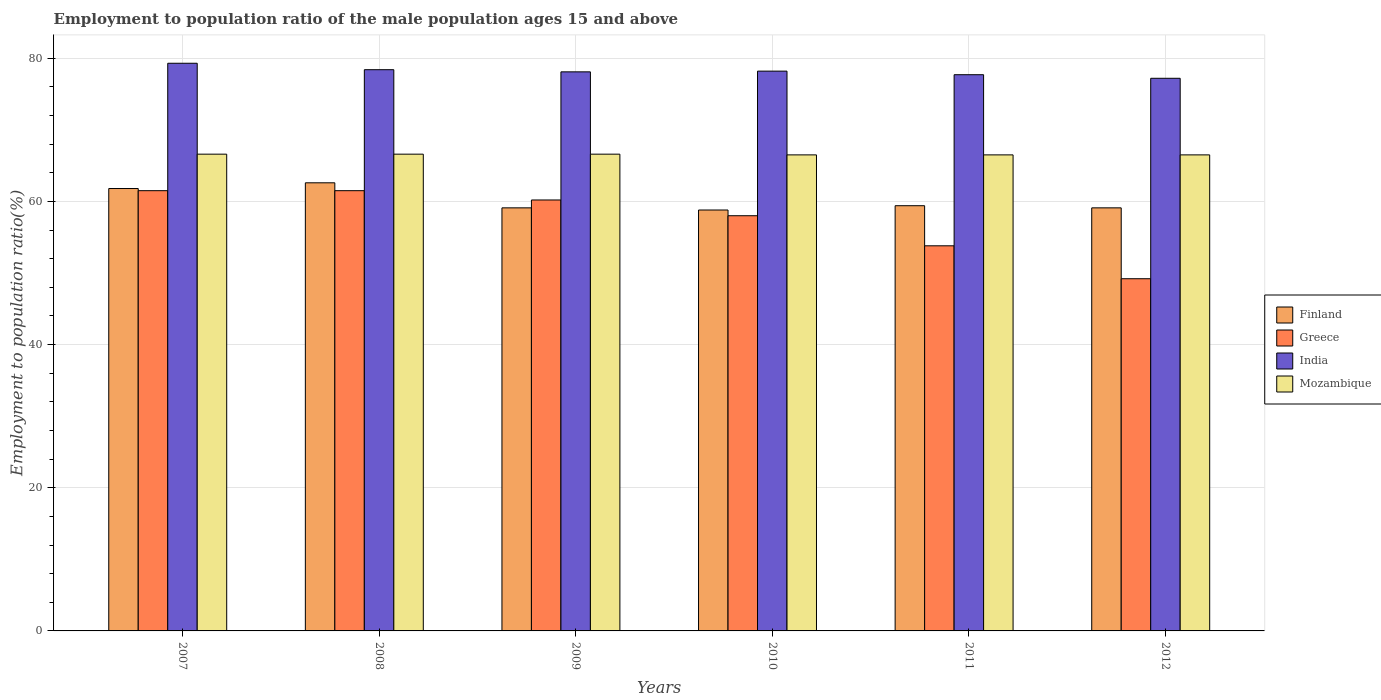Are the number of bars per tick equal to the number of legend labels?
Your answer should be very brief. Yes. Are the number of bars on each tick of the X-axis equal?
Offer a terse response. Yes. How many bars are there on the 3rd tick from the left?
Make the answer very short. 4. How many bars are there on the 4th tick from the right?
Offer a very short reply. 4. What is the label of the 4th group of bars from the left?
Offer a terse response. 2010. What is the employment to population ratio in Finland in 2012?
Offer a very short reply. 59.1. Across all years, what is the maximum employment to population ratio in India?
Provide a short and direct response. 79.3. Across all years, what is the minimum employment to population ratio in India?
Your response must be concise. 77.2. In which year was the employment to population ratio in Mozambique minimum?
Your answer should be very brief. 2010. What is the total employment to population ratio in Finland in the graph?
Your answer should be compact. 360.8. What is the difference between the employment to population ratio in Greece in 2010 and that in 2011?
Provide a succinct answer. 4.2. What is the difference between the employment to population ratio in Finland in 2010 and the employment to population ratio in Mozambique in 2009?
Offer a very short reply. -7.8. What is the average employment to population ratio in Mozambique per year?
Your answer should be very brief. 66.55. In the year 2011, what is the difference between the employment to population ratio in Mozambique and employment to population ratio in India?
Provide a short and direct response. -11.2. What is the ratio of the employment to population ratio in Greece in 2007 to that in 2010?
Provide a short and direct response. 1.06. Is the employment to population ratio in Mozambique in 2007 less than that in 2012?
Offer a terse response. No. Is the difference between the employment to population ratio in Mozambique in 2011 and 2012 greater than the difference between the employment to population ratio in India in 2011 and 2012?
Keep it short and to the point. No. What is the difference between the highest and the lowest employment to population ratio in Greece?
Ensure brevity in your answer.  12.3. Is it the case that in every year, the sum of the employment to population ratio in Mozambique and employment to population ratio in Greece is greater than the sum of employment to population ratio in Finland and employment to population ratio in India?
Your response must be concise. No. What does the 4th bar from the left in 2009 represents?
Offer a very short reply. Mozambique. What does the 3rd bar from the right in 2008 represents?
Offer a terse response. Greece. How many bars are there?
Your answer should be compact. 24. How many years are there in the graph?
Offer a terse response. 6. Does the graph contain any zero values?
Provide a succinct answer. No. Where does the legend appear in the graph?
Give a very brief answer. Center right. What is the title of the graph?
Keep it short and to the point. Employment to population ratio of the male population ages 15 and above. What is the Employment to population ratio(%) of Finland in 2007?
Keep it short and to the point. 61.8. What is the Employment to population ratio(%) in Greece in 2007?
Offer a very short reply. 61.5. What is the Employment to population ratio(%) in India in 2007?
Offer a very short reply. 79.3. What is the Employment to population ratio(%) in Mozambique in 2007?
Your answer should be compact. 66.6. What is the Employment to population ratio(%) of Finland in 2008?
Your answer should be very brief. 62.6. What is the Employment to population ratio(%) of Greece in 2008?
Keep it short and to the point. 61.5. What is the Employment to population ratio(%) in India in 2008?
Give a very brief answer. 78.4. What is the Employment to population ratio(%) of Mozambique in 2008?
Your response must be concise. 66.6. What is the Employment to population ratio(%) of Finland in 2009?
Keep it short and to the point. 59.1. What is the Employment to population ratio(%) of Greece in 2009?
Offer a terse response. 60.2. What is the Employment to population ratio(%) in India in 2009?
Offer a very short reply. 78.1. What is the Employment to population ratio(%) of Mozambique in 2009?
Give a very brief answer. 66.6. What is the Employment to population ratio(%) in Finland in 2010?
Offer a terse response. 58.8. What is the Employment to population ratio(%) in Greece in 2010?
Keep it short and to the point. 58. What is the Employment to population ratio(%) of India in 2010?
Give a very brief answer. 78.2. What is the Employment to population ratio(%) of Mozambique in 2010?
Offer a very short reply. 66.5. What is the Employment to population ratio(%) of Finland in 2011?
Your answer should be compact. 59.4. What is the Employment to population ratio(%) in Greece in 2011?
Your response must be concise. 53.8. What is the Employment to population ratio(%) in India in 2011?
Offer a very short reply. 77.7. What is the Employment to population ratio(%) of Mozambique in 2011?
Offer a terse response. 66.5. What is the Employment to population ratio(%) of Finland in 2012?
Offer a terse response. 59.1. What is the Employment to population ratio(%) in Greece in 2012?
Your answer should be very brief. 49.2. What is the Employment to population ratio(%) in India in 2012?
Offer a terse response. 77.2. What is the Employment to population ratio(%) in Mozambique in 2012?
Offer a terse response. 66.5. Across all years, what is the maximum Employment to population ratio(%) of Finland?
Offer a terse response. 62.6. Across all years, what is the maximum Employment to population ratio(%) of Greece?
Provide a succinct answer. 61.5. Across all years, what is the maximum Employment to population ratio(%) of India?
Offer a very short reply. 79.3. Across all years, what is the maximum Employment to population ratio(%) in Mozambique?
Offer a very short reply. 66.6. Across all years, what is the minimum Employment to population ratio(%) of Finland?
Your response must be concise. 58.8. Across all years, what is the minimum Employment to population ratio(%) in Greece?
Your answer should be very brief. 49.2. Across all years, what is the minimum Employment to population ratio(%) of India?
Offer a very short reply. 77.2. Across all years, what is the minimum Employment to population ratio(%) in Mozambique?
Give a very brief answer. 66.5. What is the total Employment to population ratio(%) of Finland in the graph?
Your answer should be very brief. 360.8. What is the total Employment to population ratio(%) in Greece in the graph?
Provide a short and direct response. 344.2. What is the total Employment to population ratio(%) of India in the graph?
Provide a succinct answer. 468.9. What is the total Employment to population ratio(%) of Mozambique in the graph?
Make the answer very short. 399.3. What is the difference between the Employment to population ratio(%) in Finland in 2007 and that in 2008?
Provide a succinct answer. -0.8. What is the difference between the Employment to population ratio(%) in Greece in 2007 and that in 2008?
Offer a terse response. 0. What is the difference between the Employment to population ratio(%) of India in 2007 and that in 2008?
Your response must be concise. 0.9. What is the difference between the Employment to population ratio(%) of Mozambique in 2007 and that in 2008?
Ensure brevity in your answer.  0. What is the difference between the Employment to population ratio(%) in Finland in 2007 and that in 2009?
Offer a terse response. 2.7. What is the difference between the Employment to population ratio(%) in India in 2007 and that in 2009?
Ensure brevity in your answer.  1.2. What is the difference between the Employment to population ratio(%) in Finland in 2007 and that in 2010?
Give a very brief answer. 3. What is the difference between the Employment to population ratio(%) of Greece in 2007 and that in 2010?
Offer a very short reply. 3.5. What is the difference between the Employment to population ratio(%) of Mozambique in 2007 and that in 2010?
Your response must be concise. 0.1. What is the difference between the Employment to population ratio(%) of Finland in 2007 and that in 2011?
Your response must be concise. 2.4. What is the difference between the Employment to population ratio(%) in Greece in 2007 and that in 2011?
Offer a terse response. 7.7. What is the difference between the Employment to population ratio(%) of India in 2007 and that in 2011?
Make the answer very short. 1.6. What is the difference between the Employment to population ratio(%) of Finland in 2007 and that in 2012?
Give a very brief answer. 2.7. What is the difference between the Employment to population ratio(%) of India in 2007 and that in 2012?
Give a very brief answer. 2.1. What is the difference between the Employment to population ratio(%) of India in 2008 and that in 2009?
Your answer should be compact. 0.3. What is the difference between the Employment to population ratio(%) of Mozambique in 2008 and that in 2009?
Give a very brief answer. 0. What is the difference between the Employment to population ratio(%) of Greece in 2008 and that in 2010?
Give a very brief answer. 3.5. What is the difference between the Employment to population ratio(%) in India in 2008 and that in 2010?
Your response must be concise. 0.2. What is the difference between the Employment to population ratio(%) of Greece in 2008 and that in 2011?
Offer a very short reply. 7.7. What is the difference between the Employment to population ratio(%) in Finland in 2008 and that in 2012?
Make the answer very short. 3.5. What is the difference between the Employment to population ratio(%) of Greece in 2009 and that in 2010?
Offer a very short reply. 2.2. What is the difference between the Employment to population ratio(%) of Finland in 2009 and that in 2011?
Offer a very short reply. -0.3. What is the difference between the Employment to population ratio(%) in Greece in 2009 and that in 2011?
Your response must be concise. 6.4. What is the difference between the Employment to population ratio(%) of India in 2009 and that in 2011?
Provide a succinct answer. 0.4. What is the difference between the Employment to population ratio(%) in Mozambique in 2009 and that in 2011?
Your answer should be compact. 0.1. What is the difference between the Employment to population ratio(%) of Finland in 2009 and that in 2012?
Your answer should be compact. 0. What is the difference between the Employment to population ratio(%) in Greece in 2009 and that in 2012?
Make the answer very short. 11. What is the difference between the Employment to population ratio(%) in Mozambique in 2009 and that in 2012?
Provide a short and direct response. 0.1. What is the difference between the Employment to population ratio(%) of India in 2010 and that in 2012?
Keep it short and to the point. 1. What is the difference between the Employment to population ratio(%) in Mozambique in 2010 and that in 2012?
Offer a very short reply. 0. What is the difference between the Employment to population ratio(%) of India in 2011 and that in 2012?
Provide a short and direct response. 0.5. What is the difference between the Employment to population ratio(%) of Mozambique in 2011 and that in 2012?
Provide a short and direct response. 0. What is the difference between the Employment to population ratio(%) in Finland in 2007 and the Employment to population ratio(%) in Greece in 2008?
Keep it short and to the point. 0.3. What is the difference between the Employment to population ratio(%) of Finland in 2007 and the Employment to population ratio(%) of India in 2008?
Make the answer very short. -16.6. What is the difference between the Employment to population ratio(%) in Greece in 2007 and the Employment to population ratio(%) in India in 2008?
Provide a succinct answer. -16.9. What is the difference between the Employment to population ratio(%) of Finland in 2007 and the Employment to population ratio(%) of Greece in 2009?
Your answer should be very brief. 1.6. What is the difference between the Employment to population ratio(%) of Finland in 2007 and the Employment to population ratio(%) of India in 2009?
Offer a very short reply. -16.3. What is the difference between the Employment to population ratio(%) of Finland in 2007 and the Employment to population ratio(%) of Mozambique in 2009?
Keep it short and to the point. -4.8. What is the difference between the Employment to population ratio(%) in Greece in 2007 and the Employment to population ratio(%) in India in 2009?
Keep it short and to the point. -16.6. What is the difference between the Employment to population ratio(%) of Greece in 2007 and the Employment to population ratio(%) of Mozambique in 2009?
Provide a succinct answer. -5.1. What is the difference between the Employment to population ratio(%) in Finland in 2007 and the Employment to population ratio(%) in Greece in 2010?
Your response must be concise. 3.8. What is the difference between the Employment to population ratio(%) in Finland in 2007 and the Employment to population ratio(%) in India in 2010?
Ensure brevity in your answer.  -16.4. What is the difference between the Employment to population ratio(%) of Finland in 2007 and the Employment to population ratio(%) of Mozambique in 2010?
Your response must be concise. -4.7. What is the difference between the Employment to population ratio(%) in Greece in 2007 and the Employment to population ratio(%) in India in 2010?
Ensure brevity in your answer.  -16.7. What is the difference between the Employment to population ratio(%) in Finland in 2007 and the Employment to population ratio(%) in Greece in 2011?
Ensure brevity in your answer.  8. What is the difference between the Employment to population ratio(%) of Finland in 2007 and the Employment to population ratio(%) of India in 2011?
Keep it short and to the point. -15.9. What is the difference between the Employment to population ratio(%) of Greece in 2007 and the Employment to population ratio(%) of India in 2011?
Your answer should be very brief. -16.2. What is the difference between the Employment to population ratio(%) of India in 2007 and the Employment to population ratio(%) of Mozambique in 2011?
Make the answer very short. 12.8. What is the difference between the Employment to population ratio(%) in Finland in 2007 and the Employment to population ratio(%) in India in 2012?
Offer a very short reply. -15.4. What is the difference between the Employment to population ratio(%) in Finland in 2007 and the Employment to population ratio(%) in Mozambique in 2012?
Keep it short and to the point. -4.7. What is the difference between the Employment to population ratio(%) of Greece in 2007 and the Employment to population ratio(%) of India in 2012?
Your answer should be compact. -15.7. What is the difference between the Employment to population ratio(%) of Greece in 2007 and the Employment to population ratio(%) of Mozambique in 2012?
Your answer should be compact. -5. What is the difference between the Employment to population ratio(%) of India in 2007 and the Employment to population ratio(%) of Mozambique in 2012?
Ensure brevity in your answer.  12.8. What is the difference between the Employment to population ratio(%) of Finland in 2008 and the Employment to population ratio(%) of Greece in 2009?
Give a very brief answer. 2.4. What is the difference between the Employment to population ratio(%) of Finland in 2008 and the Employment to population ratio(%) of India in 2009?
Your answer should be compact. -15.5. What is the difference between the Employment to population ratio(%) in Finland in 2008 and the Employment to population ratio(%) in Mozambique in 2009?
Offer a very short reply. -4. What is the difference between the Employment to population ratio(%) in Greece in 2008 and the Employment to population ratio(%) in India in 2009?
Offer a very short reply. -16.6. What is the difference between the Employment to population ratio(%) of Greece in 2008 and the Employment to population ratio(%) of Mozambique in 2009?
Your answer should be compact. -5.1. What is the difference between the Employment to population ratio(%) of India in 2008 and the Employment to population ratio(%) of Mozambique in 2009?
Your answer should be compact. 11.8. What is the difference between the Employment to population ratio(%) in Finland in 2008 and the Employment to population ratio(%) in India in 2010?
Give a very brief answer. -15.6. What is the difference between the Employment to population ratio(%) of Finland in 2008 and the Employment to population ratio(%) of Mozambique in 2010?
Offer a very short reply. -3.9. What is the difference between the Employment to population ratio(%) of Greece in 2008 and the Employment to population ratio(%) of India in 2010?
Provide a succinct answer. -16.7. What is the difference between the Employment to population ratio(%) of India in 2008 and the Employment to population ratio(%) of Mozambique in 2010?
Provide a short and direct response. 11.9. What is the difference between the Employment to population ratio(%) of Finland in 2008 and the Employment to population ratio(%) of India in 2011?
Your answer should be compact. -15.1. What is the difference between the Employment to population ratio(%) in Greece in 2008 and the Employment to population ratio(%) in India in 2011?
Provide a short and direct response. -16.2. What is the difference between the Employment to population ratio(%) in India in 2008 and the Employment to population ratio(%) in Mozambique in 2011?
Make the answer very short. 11.9. What is the difference between the Employment to population ratio(%) of Finland in 2008 and the Employment to population ratio(%) of Greece in 2012?
Your answer should be compact. 13.4. What is the difference between the Employment to population ratio(%) of Finland in 2008 and the Employment to population ratio(%) of India in 2012?
Provide a succinct answer. -14.6. What is the difference between the Employment to population ratio(%) in Finland in 2008 and the Employment to population ratio(%) in Mozambique in 2012?
Ensure brevity in your answer.  -3.9. What is the difference between the Employment to population ratio(%) of Greece in 2008 and the Employment to population ratio(%) of India in 2012?
Provide a succinct answer. -15.7. What is the difference between the Employment to population ratio(%) in India in 2008 and the Employment to population ratio(%) in Mozambique in 2012?
Provide a succinct answer. 11.9. What is the difference between the Employment to population ratio(%) of Finland in 2009 and the Employment to population ratio(%) of Greece in 2010?
Make the answer very short. 1.1. What is the difference between the Employment to population ratio(%) of Finland in 2009 and the Employment to population ratio(%) of India in 2010?
Provide a short and direct response. -19.1. What is the difference between the Employment to population ratio(%) in Greece in 2009 and the Employment to population ratio(%) in Mozambique in 2010?
Your answer should be very brief. -6.3. What is the difference between the Employment to population ratio(%) of India in 2009 and the Employment to population ratio(%) of Mozambique in 2010?
Your response must be concise. 11.6. What is the difference between the Employment to population ratio(%) of Finland in 2009 and the Employment to population ratio(%) of India in 2011?
Your answer should be very brief. -18.6. What is the difference between the Employment to population ratio(%) of Finland in 2009 and the Employment to population ratio(%) of Mozambique in 2011?
Provide a short and direct response. -7.4. What is the difference between the Employment to population ratio(%) in Greece in 2009 and the Employment to population ratio(%) in India in 2011?
Your answer should be compact. -17.5. What is the difference between the Employment to population ratio(%) of Finland in 2009 and the Employment to population ratio(%) of India in 2012?
Keep it short and to the point. -18.1. What is the difference between the Employment to population ratio(%) of Finland in 2009 and the Employment to population ratio(%) of Mozambique in 2012?
Keep it short and to the point. -7.4. What is the difference between the Employment to population ratio(%) in Greece in 2009 and the Employment to population ratio(%) in India in 2012?
Provide a succinct answer. -17. What is the difference between the Employment to population ratio(%) in India in 2009 and the Employment to population ratio(%) in Mozambique in 2012?
Offer a terse response. 11.6. What is the difference between the Employment to population ratio(%) of Finland in 2010 and the Employment to population ratio(%) of India in 2011?
Your response must be concise. -18.9. What is the difference between the Employment to population ratio(%) in Greece in 2010 and the Employment to population ratio(%) in India in 2011?
Make the answer very short. -19.7. What is the difference between the Employment to population ratio(%) of Greece in 2010 and the Employment to population ratio(%) of Mozambique in 2011?
Your response must be concise. -8.5. What is the difference between the Employment to population ratio(%) of India in 2010 and the Employment to population ratio(%) of Mozambique in 2011?
Keep it short and to the point. 11.7. What is the difference between the Employment to population ratio(%) of Finland in 2010 and the Employment to population ratio(%) of India in 2012?
Ensure brevity in your answer.  -18.4. What is the difference between the Employment to population ratio(%) in Finland in 2010 and the Employment to population ratio(%) in Mozambique in 2012?
Offer a very short reply. -7.7. What is the difference between the Employment to population ratio(%) in Greece in 2010 and the Employment to population ratio(%) in India in 2012?
Provide a succinct answer. -19.2. What is the difference between the Employment to population ratio(%) in Greece in 2010 and the Employment to population ratio(%) in Mozambique in 2012?
Make the answer very short. -8.5. What is the difference between the Employment to population ratio(%) in India in 2010 and the Employment to population ratio(%) in Mozambique in 2012?
Keep it short and to the point. 11.7. What is the difference between the Employment to population ratio(%) in Finland in 2011 and the Employment to population ratio(%) in Greece in 2012?
Ensure brevity in your answer.  10.2. What is the difference between the Employment to population ratio(%) in Finland in 2011 and the Employment to population ratio(%) in India in 2012?
Your answer should be compact. -17.8. What is the difference between the Employment to population ratio(%) of Finland in 2011 and the Employment to population ratio(%) of Mozambique in 2012?
Make the answer very short. -7.1. What is the difference between the Employment to population ratio(%) of Greece in 2011 and the Employment to population ratio(%) of India in 2012?
Offer a terse response. -23.4. What is the difference between the Employment to population ratio(%) of India in 2011 and the Employment to population ratio(%) of Mozambique in 2012?
Keep it short and to the point. 11.2. What is the average Employment to population ratio(%) of Finland per year?
Your answer should be very brief. 60.13. What is the average Employment to population ratio(%) in Greece per year?
Keep it short and to the point. 57.37. What is the average Employment to population ratio(%) of India per year?
Give a very brief answer. 78.15. What is the average Employment to population ratio(%) of Mozambique per year?
Ensure brevity in your answer.  66.55. In the year 2007, what is the difference between the Employment to population ratio(%) of Finland and Employment to population ratio(%) of India?
Your answer should be very brief. -17.5. In the year 2007, what is the difference between the Employment to population ratio(%) in Greece and Employment to population ratio(%) in India?
Provide a succinct answer. -17.8. In the year 2007, what is the difference between the Employment to population ratio(%) in Greece and Employment to population ratio(%) in Mozambique?
Offer a very short reply. -5.1. In the year 2008, what is the difference between the Employment to population ratio(%) of Finland and Employment to population ratio(%) of Greece?
Provide a succinct answer. 1.1. In the year 2008, what is the difference between the Employment to population ratio(%) of Finland and Employment to population ratio(%) of India?
Offer a terse response. -15.8. In the year 2008, what is the difference between the Employment to population ratio(%) of Finland and Employment to population ratio(%) of Mozambique?
Offer a terse response. -4. In the year 2008, what is the difference between the Employment to population ratio(%) in Greece and Employment to population ratio(%) in India?
Keep it short and to the point. -16.9. In the year 2008, what is the difference between the Employment to population ratio(%) in Greece and Employment to population ratio(%) in Mozambique?
Keep it short and to the point. -5.1. In the year 2008, what is the difference between the Employment to population ratio(%) of India and Employment to population ratio(%) of Mozambique?
Ensure brevity in your answer.  11.8. In the year 2009, what is the difference between the Employment to population ratio(%) of Greece and Employment to population ratio(%) of India?
Provide a short and direct response. -17.9. In the year 2010, what is the difference between the Employment to population ratio(%) in Finland and Employment to population ratio(%) in Greece?
Offer a terse response. 0.8. In the year 2010, what is the difference between the Employment to population ratio(%) in Finland and Employment to population ratio(%) in India?
Your answer should be very brief. -19.4. In the year 2010, what is the difference between the Employment to population ratio(%) in Greece and Employment to population ratio(%) in India?
Offer a terse response. -20.2. In the year 2010, what is the difference between the Employment to population ratio(%) in Greece and Employment to population ratio(%) in Mozambique?
Provide a succinct answer. -8.5. In the year 2010, what is the difference between the Employment to population ratio(%) in India and Employment to population ratio(%) in Mozambique?
Provide a short and direct response. 11.7. In the year 2011, what is the difference between the Employment to population ratio(%) of Finland and Employment to population ratio(%) of Greece?
Offer a terse response. 5.6. In the year 2011, what is the difference between the Employment to population ratio(%) of Finland and Employment to population ratio(%) of India?
Provide a succinct answer. -18.3. In the year 2011, what is the difference between the Employment to population ratio(%) of Finland and Employment to population ratio(%) of Mozambique?
Offer a very short reply. -7.1. In the year 2011, what is the difference between the Employment to population ratio(%) in Greece and Employment to population ratio(%) in India?
Provide a short and direct response. -23.9. In the year 2011, what is the difference between the Employment to population ratio(%) of Greece and Employment to population ratio(%) of Mozambique?
Provide a succinct answer. -12.7. In the year 2011, what is the difference between the Employment to population ratio(%) of India and Employment to population ratio(%) of Mozambique?
Ensure brevity in your answer.  11.2. In the year 2012, what is the difference between the Employment to population ratio(%) of Finland and Employment to population ratio(%) of India?
Provide a short and direct response. -18.1. In the year 2012, what is the difference between the Employment to population ratio(%) in Greece and Employment to population ratio(%) in India?
Offer a terse response. -28. In the year 2012, what is the difference between the Employment to population ratio(%) in Greece and Employment to population ratio(%) in Mozambique?
Give a very brief answer. -17.3. In the year 2012, what is the difference between the Employment to population ratio(%) of India and Employment to population ratio(%) of Mozambique?
Ensure brevity in your answer.  10.7. What is the ratio of the Employment to population ratio(%) in Finland in 2007 to that in 2008?
Offer a very short reply. 0.99. What is the ratio of the Employment to population ratio(%) of Greece in 2007 to that in 2008?
Offer a terse response. 1. What is the ratio of the Employment to population ratio(%) in India in 2007 to that in 2008?
Make the answer very short. 1.01. What is the ratio of the Employment to population ratio(%) of Mozambique in 2007 to that in 2008?
Keep it short and to the point. 1. What is the ratio of the Employment to population ratio(%) of Finland in 2007 to that in 2009?
Give a very brief answer. 1.05. What is the ratio of the Employment to population ratio(%) of Greece in 2007 to that in 2009?
Offer a very short reply. 1.02. What is the ratio of the Employment to population ratio(%) of India in 2007 to that in 2009?
Offer a terse response. 1.02. What is the ratio of the Employment to population ratio(%) in Mozambique in 2007 to that in 2009?
Your response must be concise. 1. What is the ratio of the Employment to population ratio(%) in Finland in 2007 to that in 2010?
Offer a terse response. 1.05. What is the ratio of the Employment to population ratio(%) in Greece in 2007 to that in 2010?
Ensure brevity in your answer.  1.06. What is the ratio of the Employment to population ratio(%) of India in 2007 to that in 2010?
Provide a succinct answer. 1.01. What is the ratio of the Employment to population ratio(%) of Mozambique in 2007 to that in 2010?
Your response must be concise. 1. What is the ratio of the Employment to population ratio(%) of Finland in 2007 to that in 2011?
Give a very brief answer. 1.04. What is the ratio of the Employment to population ratio(%) in Greece in 2007 to that in 2011?
Offer a very short reply. 1.14. What is the ratio of the Employment to population ratio(%) of India in 2007 to that in 2011?
Provide a short and direct response. 1.02. What is the ratio of the Employment to population ratio(%) in Finland in 2007 to that in 2012?
Make the answer very short. 1.05. What is the ratio of the Employment to population ratio(%) in Greece in 2007 to that in 2012?
Offer a terse response. 1.25. What is the ratio of the Employment to population ratio(%) in India in 2007 to that in 2012?
Your answer should be very brief. 1.03. What is the ratio of the Employment to population ratio(%) of Mozambique in 2007 to that in 2012?
Your response must be concise. 1. What is the ratio of the Employment to population ratio(%) in Finland in 2008 to that in 2009?
Make the answer very short. 1.06. What is the ratio of the Employment to population ratio(%) of Greece in 2008 to that in 2009?
Ensure brevity in your answer.  1.02. What is the ratio of the Employment to population ratio(%) in Finland in 2008 to that in 2010?
Offer a terse response. 1.06. What is the ratio of the Employment to population ratio(%) of Greece in 2008 to that in 2010?
Ensure brevity in your answer.  1.06. What is the ratio of the Employment to population ratio(%) of India in 2008 to that in 2010?
Your answer should be compact. 1. What is the ratio of the Employment to population ratio(%) in Mozambique in 2008 to that in 2010?
Give a very brief answer. 1. What is the ratio of the Employment to population ratio(%) of Finland in 2008 to that in 2011?
Make the answer very short. 1.05. What is the ratio of the Employment to population ratio(%) in Greece in 2008 to that in 2011?
Make the answer very short. 1.14. What is the ratio of the Employment to population ratio(%) of Finland in 2008 to that in 2012?
Offer a very short reply. 1.06. What is the ratio of the Employment to population ratio(%) in Greece in 2008 to that in 2012?
Make the answer very short. 1.25. What is the ratio of the Employment to population ratio(%) in India in 2008 to that in 2012?
Give a very brief answer. 1.02. What is the ratio of the Employment to population ratio(%) of Finland in 2009 to that in 2010?
Offer a very short reply. 1.01. What is the ratio of the Employment to population ratio(%) of Greece in 2009 to that in 2010?
Your answer should be very brief. 1.04. What is the ratio of the Employment to population ratio(%) of India in 2009 to that in 2010?
Make the answer very short. 1. What is the ratio of the Employment to population ratio(%) of Finland in 2009 to that in 2011?
Your answer should be very brief. 0.99. What is the ratio of the Employment to population ratio(%) in Greece in 2009 to that in 2011?
Ensure brevity in your answer.  1.12. What is the ratio of the Employment to population ratio(%) in Mozambique in 2009 to that in 2011?
Your answer should be very brief. 1. What is the ratio of the Employment to population ratio(%) in Greece in 2009 to that in 2012?
Provide a succinct answer. 1.22. What is the ratio of the Employment to population ratio(%) of India in 2009 to that in 2012?
Provide a succinct answer. 1.01. What is the ratio of the Employment to population ratio(%) in Greece in 2010 to that in 2011?
Keep it short and to the point. 1.08. What is the ratio of the Employment to population ratio(%) in India in 2010 to that in 2011?
Provide a succinct answer. 1.01. What is the ratio of the Employment to population ratio(%) of Mozambique in 2010 to that in 2011?
Give a very brief answer. 1. What is the ratio of the Employment to population ratio(%) in Finland in 2010 to that in 2012?
Keep it short and to the point. 0.99. What is the ratio of the Employment to population ratio(%) in Greece in 2010 to that in 2012?
Your response must be concise. 1.18. What is the ratio of the Employment to population ratio(%) in India in 2010 to that in 2012?
Keep it short and to the point. 1.01. What is the ratio of the Employment to population ratio(%) in Greece in 2011 to that in 2012?
Make the answer very short. 1.09. What is the ratio of the Employment to population ratio(%) in Mozambique in 2011 to that in 2012?
Provide a short and direct response. 1. What is the difference between the highest and the second highest Employment to population ratio(%) in Greece?
Your answer should be very brief. 0. What is the difference between the highest and the second highest Employment to population ratio(%) in India?
Make the answer very short. 0.9. What is the difference between the highest and the lowest Employment to population ratio(%) in India?
Keep it short and to the point. 2.1. What is the difference between the highest and the lowest Employment to population ratio(%) of Mozambique?
Make the answer very short. 0.1. 